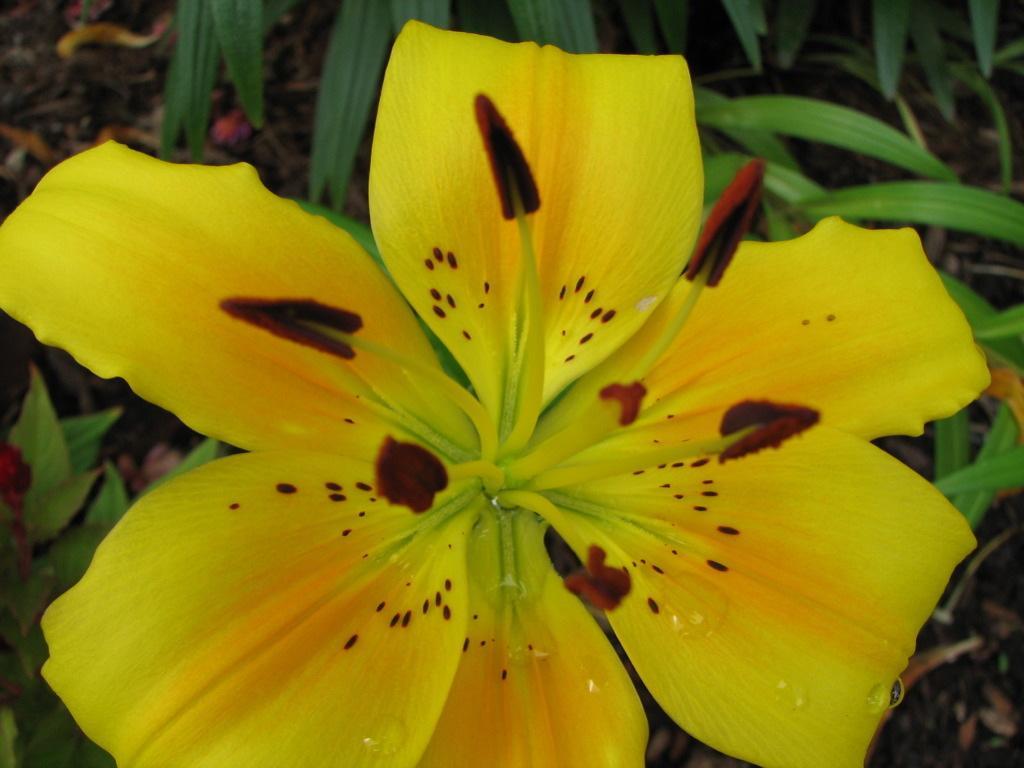Could you give a brief overview of what you see in this image? In this picture we can see a flower and in the background we can see leaves, soil. 